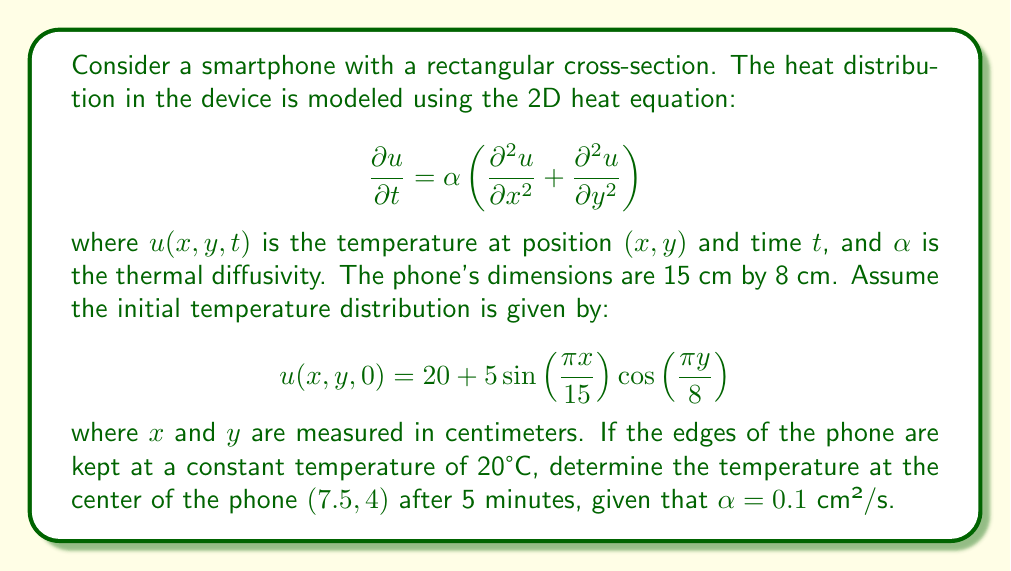Solve this math problem. To solve this problem, we need to use the separation of variables method for the heat equation with Dirichlet boundary conditions. The solution will be of the form:

$$u(x,y,t) = \sum_{m=1}^{\infty}\sum_{n=1}^{\infty} A_{mn}\sin\left(\frac{m\pi x}{L_x}\right)\sin\left(\frac{n\pi y}{L_y}\right)e^{-\alpha\left(\frac{m^2\pi^2}{L_x^2}+\frac{n^2\pi^2}{L_y^2}\right)t}$$

where $L_x = 15$ cm and $L_y = 8$ cm are the dimensions of the phone.

1) First, we need to find the coefficients $A_{mn}$ that satisfy the initial condition:

   $$20 + 5\sin\left(\frac{\pi x}{15}\right)\cos\left(\frac{\pi y}{8}\right) = \sum_{m=1}^{\infty}\sum_{n=1}^{\infty} A_{mn}\sin\left(\frac{m\pi x}{15}\right)\sin\left(\frac{n\pi y}{8}\right)$$

2) Comparing the terms, we can see that $m=1$ and $n=1$ are the only non-zero terms, with:

   $$A_{11} = 5 \cdot \frac{4}{\pi} = \frac{20}{\pi}$$

3) The solution then becomes:

   $$u(x,y,t) = 20 + \frac{20}{\pi}\sin\left(\frac{\pi x}{15}\right)\sin\left(\frac{\pi y}{8}\right)e^{-\alpha\left(\frac{\pi^2}{15^2}+\frac{\pi^2}{8^2}\right)t}$$

4) Now, we need to evaluate this at the center point $(7.5, 4)$ after 5 minutes (300 seconds):

   $$u(7.5, 4, 300) = 20 + \frac{20}{\pi}\sin\left(\frac{\pi}{2}\right)\sin\left(\frac{\pi}{2}\right)e^{-0.1\left(\frac{\pi^2}{15^2}+\frac{\pi^2}{8^2}\right)300}$$

5) Simplifying:

   $$u(7.5, 4, 300) = 20 + \frac{20}{\pi}e^{-0.1\left(\frac{\pi^2}{225}+\frac{\pi^2}{64}\right)300}$$

6) Calculating the exponent:

   $$-0.1\left(\frac{\pi^2}{225}+\frac{\pi^2}{64}\right)300 \approx -1.6815$$

7) Therefore:

   $$u(7.5, 4, 300) \approx 20 + \frac{20}{\pi}e^{-1.6815} \approx 23.74$$
Answer: The temperature at the center of the phone after 5 minutes is approximately 23.74°C. 